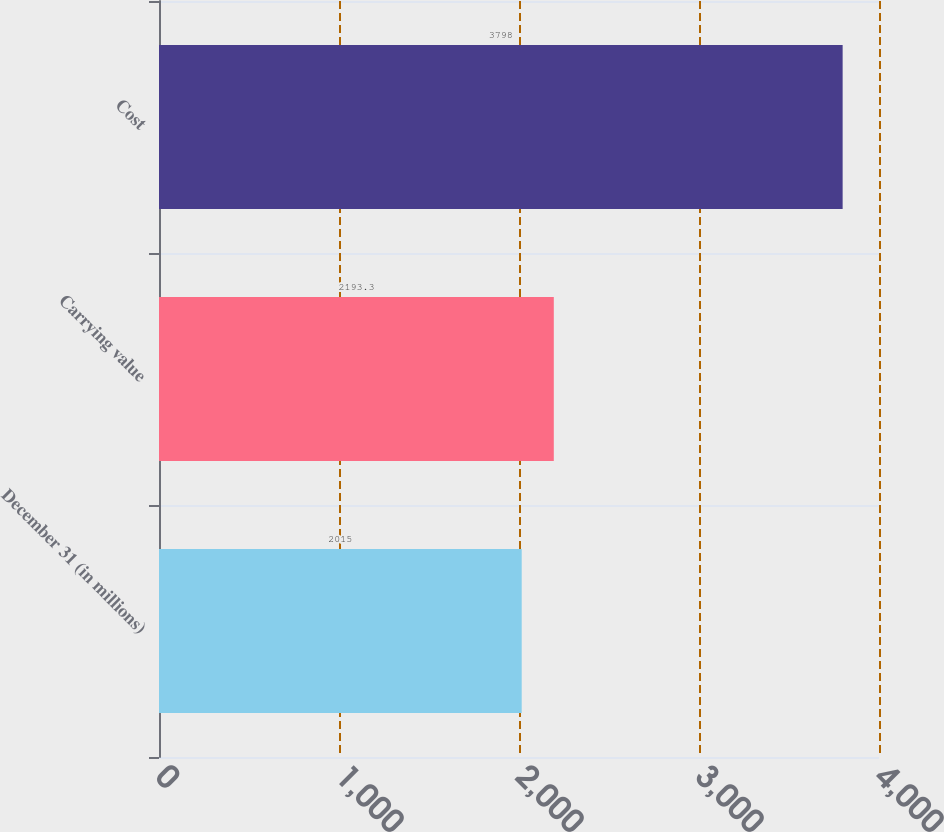<chart> <loc_0><loc_0><loc_500><loc_500><bar_chart><fcel>December 31 (in millions)<fcel>Carrying value<fcel>Cost<nl><fcel>2015<fcel>2193.3<fcel>3798<nl></chart> 